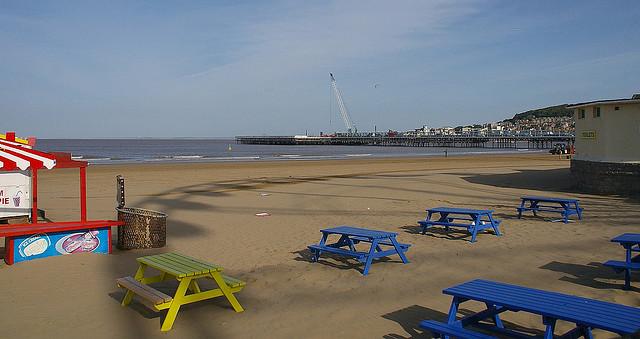How is the weather in the photo?
Write a very short answer. Sunny. Does this building have more than one level?
Write a very short answer. No. Is this a bathroom?
Answer briefly. No. What is the name of the ship these people are on?
Concise answer only. None. Is there a barcode on the picture?
Quick response, please. No. What is prepare on this place?
Be succinct. Sand. Is the toilet indoors or outdoors?
Keep it brief. Indoors. What location is shown?
Write a very short answer. Beach. Are all picnic tables blue?
Quick response, please. No. Are there a lot of yellow umbrellas on the beach?
Give a very brief answer. No. What color's are the tent?
Write a very short answer. Red and white. Are the picnic tables situated on grass or sand?
Give a very brief answer. Sand. What items are making the shadows?
Quick response, please. Tables. Where are the pulleys?
Write a very short answer. Crane. What color is the roof of the gazebo?
Write a very short answer. Red and white. Is the picture taken in the evening?
Quick response, please. No. Is this a breathtaking picture?
Keep it brief. Yes. What time of the day is this?
Write a very short answer. Morning. What is on the ground?
Answer briefly. Sand. 